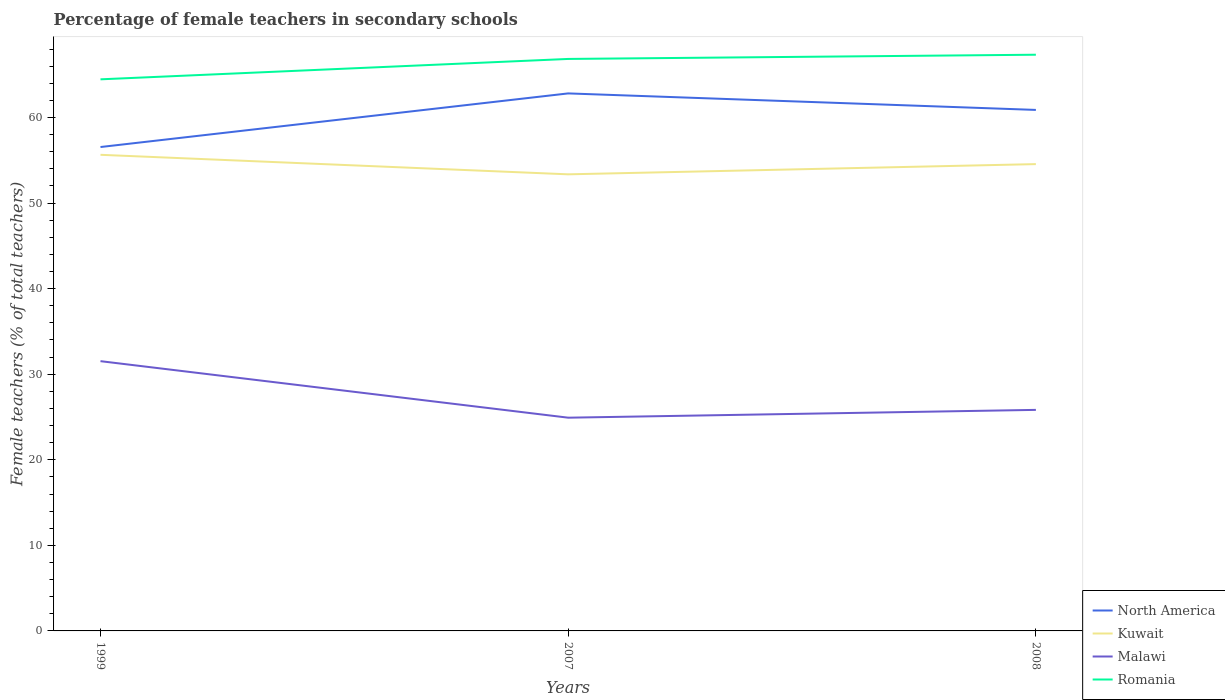How many different coloured lines are there?
Your response must be concise. 4. Does the line corresponding to North America intersect with the line corresponding to Malawi?
Make the answer very short. No. Across all years, what is the maximum percentage of female teachers in Romania?
Provide a succinct answer. 64.46. In which year was the percentage of female teachers in North America maximum?
Give a very brief answer. 1999. What is the total percentage of female teachers in Malawi in the graph?
Offer a very short reply. -0.91. What is the difference between the highest and the second highest percentage of female teachers in Romania?
Offer a very short reply. 2.87. What is the difference between the highest and the lowest percentage of female teachers in Kuwait?
Keep it short and to the point. 2. What is the difference between two consecutive major ticks on the Y-axis?
Keep it short and to the point. 10. Are the values on the major ticks of Y-axis written in scientific E-notation?
Keep it short and to the point. No. Does the graph contain grids?
Ensure brevity in your answer.  No. Where does the legend appear in the graph?
Provide a succinct answer. Bottom right. What is the title of the graph?
Keep it short and to the point. Percentage of female teachers in secondary schools. What is the label or title of the X-axis?
Offer a very short reply. Years. What is the label or title of the Y-axis?
Your response must be concise. Female teachers (% of total teachers). What is the Female teachers (% of total teachers) of North America in 1999?
Ensure brevity in your answer.  56.55. What is the Female teachers (% of total teachers) in Kuwait in 1999?
Offer a very short reply. 55.64. What is the Female teachers (% of total teachers) of Malawi in 1999?
Ensure brevity in your answer.  31.52. What is the Female teachers (% of total teachers) of Romania in 1999?
Make the answer very short. 64.46. What is the Female teachers (% of total teachers) in North America in 2007?
Your answer should be very brief. 62.81. What is the Female teachers (% of total teachers) of Kuwait in 2007?
Keep it short and to the point. 53.36. What is the Female teachers (% of total teachers) in Malawi in 2007?
Keep it short and to the point. 24.92. What is the Female teachers (% of total teachers) of Romania in 2007?
Your answer should be compact. 66.84. What is the Female teachers (% of total teachers) in North America in 2008?
Provide a succinct answer. 60.88. What is the Female teachers (% of total teachers) in Kuwait in 2008?
Offer a very short reply. 54.55. What is the Female teachers (% of total teachers) in Malawi in 2008?
Ensure brevity in your answer.  25.83. What is the Female teachers (% of total teachers) in Romania in 2008?
Offer a very short reply. 67.33. Across all years, what is the maximum Female teachers (% of total teachers) of North America?
Your response must be concise. 62.81. Across all years, what is the maximum Female teachers (% of total teachers) in Kuwait?
Your answer should be very brief. 55.64. Across all years, what is the maximum Female teachers (% of total teachers) of Malawi?
Your response must be concise. 31.52. Across all years, what is the maximum Female teachers (% of total teachers) in Romania?
Keep it short and to the point. 67.33. Across all years, what is the minimum Female teachers (% of total teachers) of North America?
Offer a terse response. 56.55. Across all years, what is the minimum Female teachers (% of total teachers) in Kuwait?
Give a very brief answer. 53.36. Across all years, what is the minimum Female teachers (% of total teachers) of Malawi?
Give a very brief answer. 24.92. Across all years, what is the minimum Female teachers (% of total teachers) of Romania?
Your response must be concise. 64.46. What is the total Female teachers (% of total teachers) in North America in the graph?
Keep it short and to the point. 180.24. What is the total Female teachers (% of total teachers) of Kuwait in the graph?
Ensure brevity in your answer.  163.54. What is the total Female teachers (% of total teachers) in Malawi in the graph?
Provide a succinct answer. 82.27. What is the total Female teachers (% of total teachers) in Romania in the graph?
Provide a short and direct response. 198.63. What is the difference between the Female teachers (% of total teachers) in North America in 1999 and that in 2007?
Provide a succinct answer. -6.27. What is the difference between the Female teachers (% of total teachers) in Kuwait in 1999 and that in 2007?
Provide a short and direct response. 2.28. What is the difference between the Female teachers (% of total teachers) in Malawi in 1999 and that in 2007?
Make the answer very short. 6.61. What is the difference between the Female teachers (% of total teachers) in Romania in 1999 and that in 2007?
Offer a very short reply. -2.38. What is the difference between the Female teachers (% of total teachers) of North America in 1999 and that in 2008?
Your answer should be compact. -4.34. What is the difference between the Female teachers (% of total teachers) of Kuwait in 1999 and that in 2008?
Ensure brevity in your answer.  1.09. What is the difference between the Female teachers (% of total teachers) of Malawi in 1999 and that in 2008?
Ensure brevity in your answer.  5.69. What is the difference between the Female teachers (% of total teachers) in Romania in 1999 and that in 2008?
Your answer should be very brief. -2.87. What is the difference between the Female teachers (% of total teachers) in North America in 2007 and that in 2008?
Offer a very short reply. 1.93. What is the difference between the Female teachers (% of total teachers) of Kuwait in 2007 and that in 2008?
Offer a very short reply. -1.19. What is the difference between the Female teachers (% of total teachers) in Malawi in 2007 and that in 2008?
Keep it short and to the point. -0.91. What is the difference between the Female teachers (% of total teachers) in Romania in 2007 and that in 2008?
Provide a succinct answer. -0.49. What is the difference between the Female teachers (% of total teachers) in North America in 1999 and the Female teachers (% of total teachers) in Kuwait in 2007?
Provide a succinct answer. 3.19. What is the difference between the Female teachers (% of total teachers) of North America in 1999 and the Female teachers (% of total teachers) of Malawi in 2007?
Offer a very short reply. 31.63. What is the difference between the Female teachers (% of total teachers) in North America in 1999 and the Female teachers (% of total teachers) in Romania in 2007?
Offer a very short reply. -10.29. What is the difference between the Female teachers (% of total teachers) of Kuwait in 1999 and the Female teachers (% of total teachers) of Malawi in 2007?
Ensure brevity in your answer.  30.72. What is the difference between the Female teachers (% of total teachers) in Kuwait in 1999 and the Female teachers (% of total teachers) in Romania in 2007?
Your answer should be compact. -11.2. What is the difference between the Female teachers (% of total teachers) of Malawi in 1999 and the Female teachers (% of total teachers) of Romania in 2007?
Your answer should be compact. -35.32. What is the difference between the Female teachers (% of total teachers) in North America in 1999 and the Female teachers (% of total teachers) in Kuwait in 2008?
Make the answer very short. 2. What is the difference between the Female teachers (% of total teachers) in North America in 1999 and the Female teachers (% of total teachers) in Malawi in 2008?
Keep it short and to the point. 30.72. What is the difference between the Female teachers (% of total teachers) of North America in 1999 and the Female teachers (% of total teachers) of Romania in 2008?
Provide a succinct answer. -10.79. What is the difference between the Female teachers (% of total teachers) of Kuwait in 1999 and the Female teachers (% of total teachers) of Malawi in 2008?
Ensure brevity in your answer.  29.81. What is the difference between the Female teachers (% of total teachers) of Kuwait in 1999 and the Female teachers (% of total teachers) of Romania in 2008?
Your answer should be compact. -11.7. What is the difference between the Female teachers (% of total teachers) of Malawi in 1999 and the Female teachers (% of total teachers) of Romania in 2008?
Make the answer very short. -35.81. What is the difference between the Female teachers (% of total teachers) of North America in 2007 and the Female teachers (% of total teachers) of Kuwait in 2008?
Make the answer very short. 8.26. What is the difference between the Female teachers (% of total teachers) of North America in 2007 and the Female teachers (% of total teachers) of Malawi in 2008?
Ensure brevity in your answer.  36.98. What is the difference between the Female teachers (% of total teachers) of North America in 2007 and the Female teachers (% of total teachers) of Romania in 2008?
Give a very brief answer. -4.52. What is the difference between the Female teachers (% of total teachers) of Kuwait in 2007 and the Female teachers (% of total teachers) of Malawi in 2008?
Provide a succinct answer. 27.53. What is the difference between the Female teachers (% of total teachers) of Kuwait in 2007 and the Female teachers (% of total teachers) of Romania in 2008?
Your answer should be very brief. -13.98. What is the difference between the Female teachers (% of total teachers) in Malawi in 2007 and the Female teachers (% of total teachers) in Romania in 2008?
Offer a terse response. -42.41. What is the average Female teachers (% of total teachers) of North America per year?
Ensure brevity in your answer.  60.08. What is the average Female teachers (% of total teachers) of Kuwait per year?
Provide a short and direct response. 54.51. What is the average Female teachers (% of total teachers) of Malawi per year?
Keep it short and to the point. 27.42. What is the average Female teachers (% of total teachers) in Romania per year?
Keep it short and to the point. 66.21. In the year 1999, what is the difference between the Female teachers (% of total teachers) in North America and Female teachers (% of total teachers) in Kuwait?
Provide a succinct answer. 0.91. In the year 1999, what is the difference between the Female teachers (% of total teachers) in North America and Female teachers (% of total teachers) in Malawi?
Ensure brevity in your answer.  25.02. In the year 1999, what is the difference between the Female teachers (% of total teachers) in North America and Female teachers (% of total teachers) in Romania?
Offer a terse response. -7.91. In the year 1999, what is the difference between the Female teachers (% of total teachers) in Kuwait and Female teachers (% of total teachers) in Malawi?
Make the answer very short. 24.11. In the year 1999, what is the difference between the Female teachers (% of total teachers) of Kuwait and Female teachers (% of total teachers) of Romania?
Your answer should be very brief. -8.82. In the year 1999, what is the difference between the Female teachers (% of total teachers) of Malawi and Female teachers (% of total teachers) of Romania?
Ensure brevity in your answer.  -32.93. In the year 2007, what is the difference between the Female teachers (% of total teachers) of North America and Female teachers (% of total teachers) of Kuwait?
Ensure brevity in your answer.  9.46. In the year 2007, what is the difference between the Female teachers (% of total teachers) of North America and Female teachers (% of total teachers) of Malawi?
Ensure brevity in your answer.  37.89. In the year 2007, what is the difference between the Female teachers (% of total teachers) in North America and Female teachers (% of total teachers) in Romania?
Give a very brief answer. -4.03. In the year 2007, what is the difference between the Female teachers (% of total teachers) in Kuwait and Female teachers (% of total teachers) in Malawi?
Provide a short and direct response. 28.44. In the year 2007, what is the difference between the Female teachers (% of total teachers) in Kuwait and Female teachers (% of total teachers) in Romania?
Ensure brevity in your answer.  -13.48. In the year 2007, what is the difference between the Female teachers (% of total teachers) in Malawi and Female teachers (% of total teachers) in Romania?
Ensure brevity in your answer.  -41.92. In the year 2008, what is the difference between the Female teachers (% of total teachers) of North America and Female teachers (% of total teachers) of Kuwait?
Keep it short and to the point. 6.33. In the year 2008, what is the difference between the Female teachers (% of total teachers) of North America and Female teachers (% of total teachers) of Malawi?
Offer a terse response. 35.05. In the year 2008, what is the difference between the Female teachers (% of total teachers) in North America and Female teachers (% of total teachers) in Romania?
Offer a terse response. -6.45. In the year 2008, what is the difference between the Female teachers (% of total teachers) in Kuwait and Female teachers (% of total teachers) in Malawi?
Provide a short and direct response. 28.72. In the year 2008, what is the difference between the Female teachers (% of total teachers) in Kuwait and Female teachers (% of total teachers) in Romania?
Your answer should be very brief. -12.78. In the year 2008, what is the difference between the Female teachers (% of total teachers) of Malawi and Female teachers (% of total teachers) of Romania?
Make the answer very short. -41.5. What is the ratio of the Female teachers (% of total teachers) of North America in 1999 to that in 2007?
Your answer should be very brief. 0.9. What is the ratio of the Female teachers (% of total teachers) of Kuwait in 1999 to that in 2007?
Make the answer very short. 1.04. What is the ratio of the Female teachers (% of total teachers) in Malawi in 1999 to that in 2007?
Your response must be concise. 1.27. What is the ratio of the Female teachers (% of total teachers) of Romania in 1999 to that in 2007?
Offer a terse response. 0.96. What is the ratio of the Female teachers (% of total teachers) in North America in 1999 to that in 2008?
Give a very brief answer. 0.93. What is the ratio of the Female teachers (% of total teachers) of Kuwait in 1999 to that in 2008?
Make the answer very short. 1.02. What is the ratio of the Female teachers (% of total teachers) of Malawi in 1999 to that in 2008?
Offer a terse response. 1.22. What is the ratio of the Female teachers (% of total teachers) in Romania in 1999 to that in 2008?
Provide a succinct answer. 0.96. What is the ratio of the Female teachers (% of total teachers) in North America in 2007 to that in 2008?
Your answer should be compact. 1.03. What is the ratio of the Female teachers (% of total teachers) of Kuwait in 2007 to that in 2008?
Offer a terse response. 0.98. What is the ratio of the Female teachers (% of total teachers) of Malawi in 2007 to that in 2008?
Provide a succinct answer. 0.96. What is the ratio of the Female teachers (% of total teachers) in Romania in 2007 to that in 2008?
Your answer should be very brief. 0.99. What is the difference between the highest and the second highest Female teachers (% of total teachers) of North America?
Keep it short and to the point. 1.93. What is the difference between the highest and the second highest Female teachers (% of total teachers) of Kuwait?
Your response must be concise. 1.09. What is the difference between the highest and the second highest Female teachers (% of total teachers) of Malawi?
Your response must be concise. 5.69. What is the difference between the highest and the second highest Female teachers (% of total teachers) of Romania?
Provide a short and direct response. 0.49. What is the difference between the highest and the lowest Female teachers (% of total teachers) of North America?
Provide a succinct answer. 6.27. What is the difference between the highest and the lowest Female teachers (% of total teachers) of Kuwait?
Offer a very short reply. 2.28. What is the difference between the highest and the lowest Female teachers (% of total teachers) of Malawi?
Offer a very short reply. 6.61. What is the difference between the highest and the lowest Female teachers (% of total teachers) of Romania?
Provide a short and direct response. 2.87. 